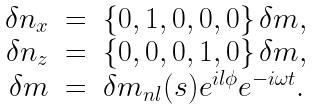Convert formula to latex. <formula><loc_0><loc_0><loc_500><loc_500>\begin{array} { r c l } \delta { n } _ { x } & = & \{ 0 , 1 , 0 , 0 , 0 \} \, \delta m , \\ \delta { n } _ { z } & = & \{ 0 , 0 , 0 , 1 , 0 \} \, \delta m , \\ \delta m & = & \delta m _ { n l } ( s ) e ^ { i l \phi } e ^ { - i \omega t } . \end{array}</formula> 